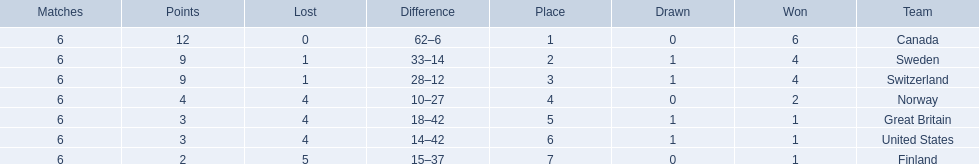What are the names of the countries? Canada, Sweden, Switzerland, Norway, Great Britain, United States, Finland. How many wins did switzerland have? 4. How many wins did great britain have? 1. I'm looking to parse the entire table for insights. Could you assist me with that? {'header': ['Matches', 'Points', 'Lost', 'Difference', 'Place', 'Drawn', 'Won', 'Team'], 'rows': [['6', '12', '0', '62–6', '1', '0', '6', 'Canada'], ['6', '9', '1', '33–14', '2', '1', '4', 'Sweden'], ['6', '9', '1', '28–12', '3', '1', '4', 'Switzerland'], ['6', '4', '4', '10–27', '4', '0', '2', 'Norway'], ['6', '3', '4', '18–42', '5', '1', '1', 'Great Britain'], ['6', '3', '4', '14–42', '6', '1', '1', 'United States'], ['6', '2', '5', '15–37', '7', '0', '1', 'Finland']]} Which country had more wins, great britain or switzerland? Switzerland. 